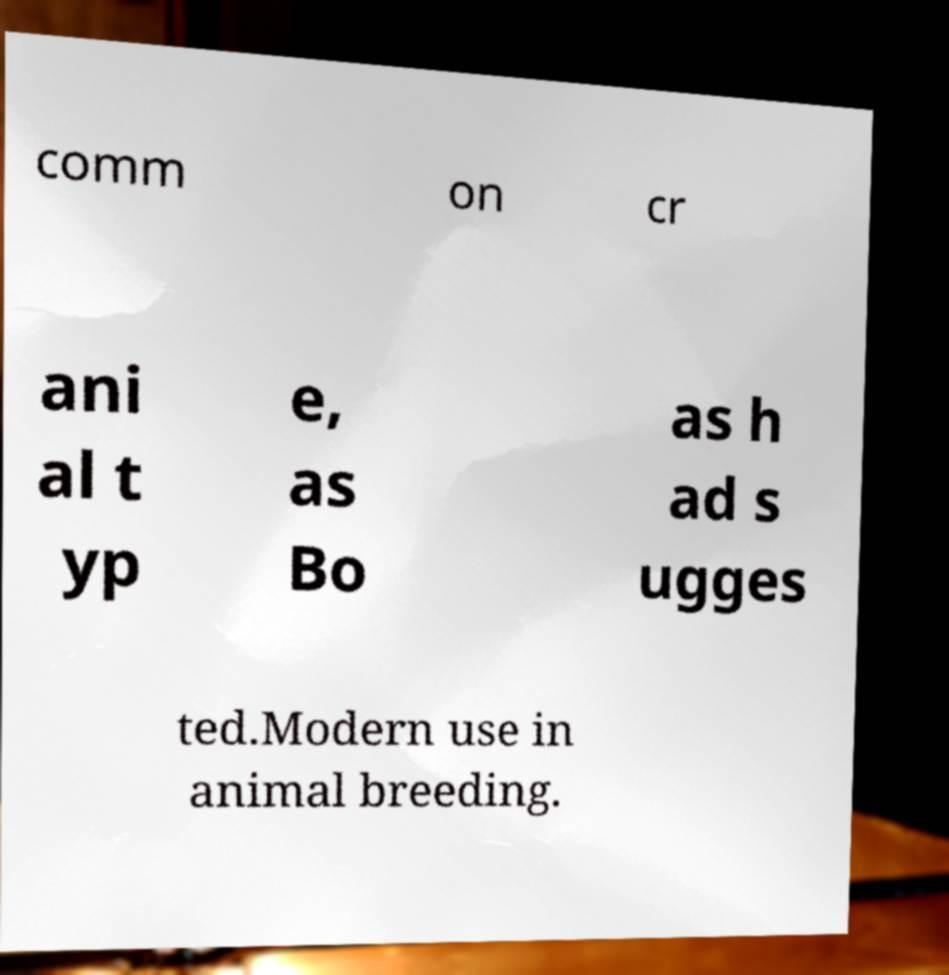There's text embedded in this image that I need extracted. Can you transcribe it verbatim? comm on cr ani al t yp e, as Bo as h ad s ugges ted.Modern use in animal breeding. 